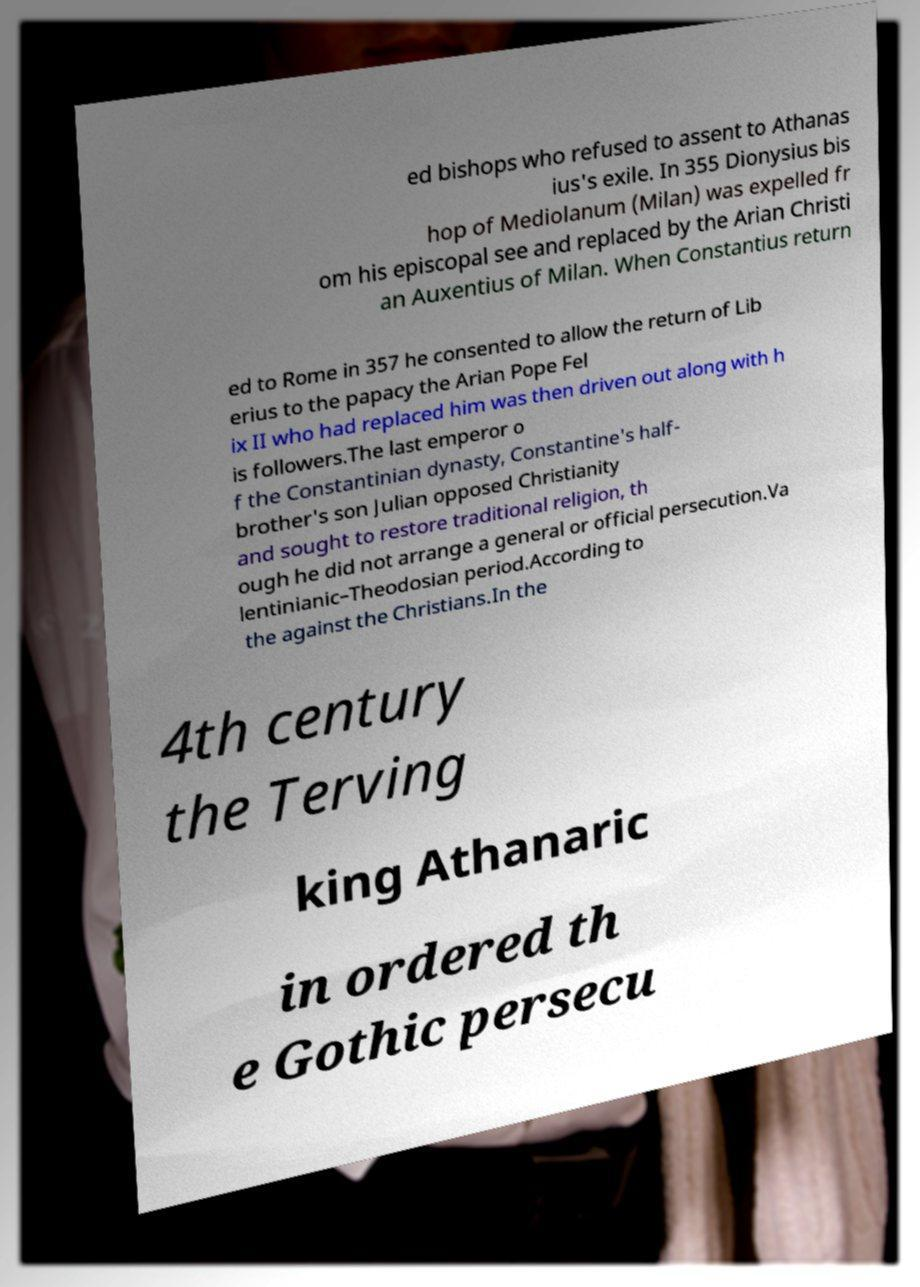For documentation purposes, I need the text within this image transcribed. Could you provide that? ed bishops who refused to assent to Athanas ius's exile. In 355 Dionysius bis hop of Mediolanum (Milan) was expelled fr om his episcopal see and replaced by the Arian Christi an Auxentius of Milan. When Constantius return ed to Rome in 357 he consented to allow the return of Lib erius to the papacy the Arian Pope Fel ix II who had replaced him was then driven out along with h is followers.The last emperor o f the Constantinian dynasty, Constantine's half- brother's son Julian opposed Christianity and sought to restore traditional religion, th ough he did not arrange a general or official persecution.Va lentinianic–Theodosian period.According to the against the Christians.In the 4th century the Terving king Athanaric in ordered th e Gothic persecu 